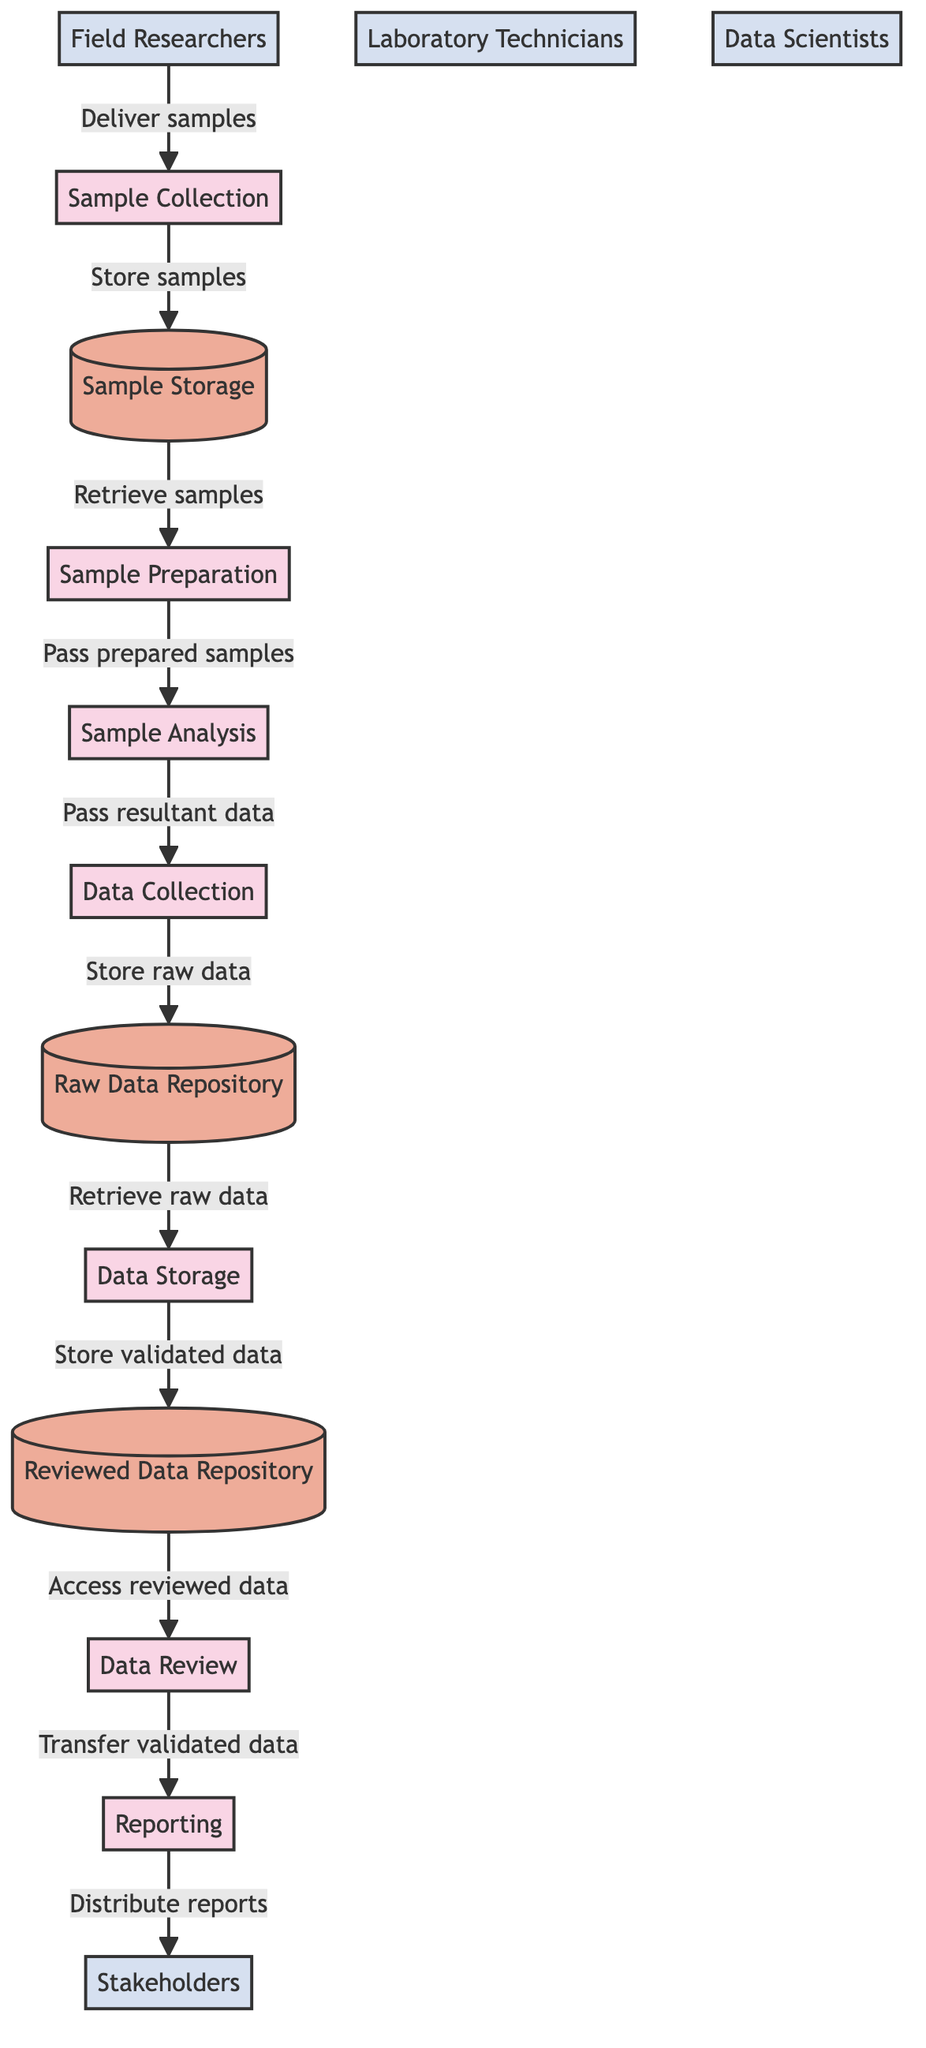What is the first process in the diagram? The diagram starts with the process labeled "Sample Collection," which is the initial step of the workflow where samples are gathered.
Answer: Sample Collection How many processes are there in total? Counting the processes labeled in the diagram, we find there are seven distinct processes involved in the environmental sample analysis.
Answer: Seven What is the role of E2 in the workflow? E2, which represents "Laboratory Technicians," is involved in handling the preparation and analysis of samples in the laboratory after they have been collected.
Answer: Laboratory Technicians What data store receives raw analytical data? The "Raw Data Repository" is the designated database where raw analytical data collected from the sample analysis is stored.
Answer: Raw Data Repository Which process follows Sample Preparation? The process that comes immediately after "Sample Preparation" is "Sample Analysis," indicating the execution of laboratory tests on the prepared samples.
Answer: Sample Analysis How does validated data reach stakeholders? Validated data is transferred from the "Data Review" process to the "Reporting" process, which then generates reports that are distributed to the stakeholders.
Answer: Reporting What is the purpose of the Data Storage process? The purpose of the "Data Storage" process is to securely store the collected data in a database for access and future analysis.
Answer: Store collected data Which external entity delivers samples to the first process? The external entity responsible for delivering samples to the first process "Sample Collection" is "Field Researchers," who collect the samples from the environment.
Answer: Field Researchers In what order do samples progress from collection to review? The sample workflow begins with "Sample Collection," followed by "Sample Preparation," then "Sample Analysis," then "Data Collection," "Data Storage," and finally "Data Review."
Answer: Sample Collection, Sample Preparation, Sample Analysis, Data Collection, Data Storage, Data Review 